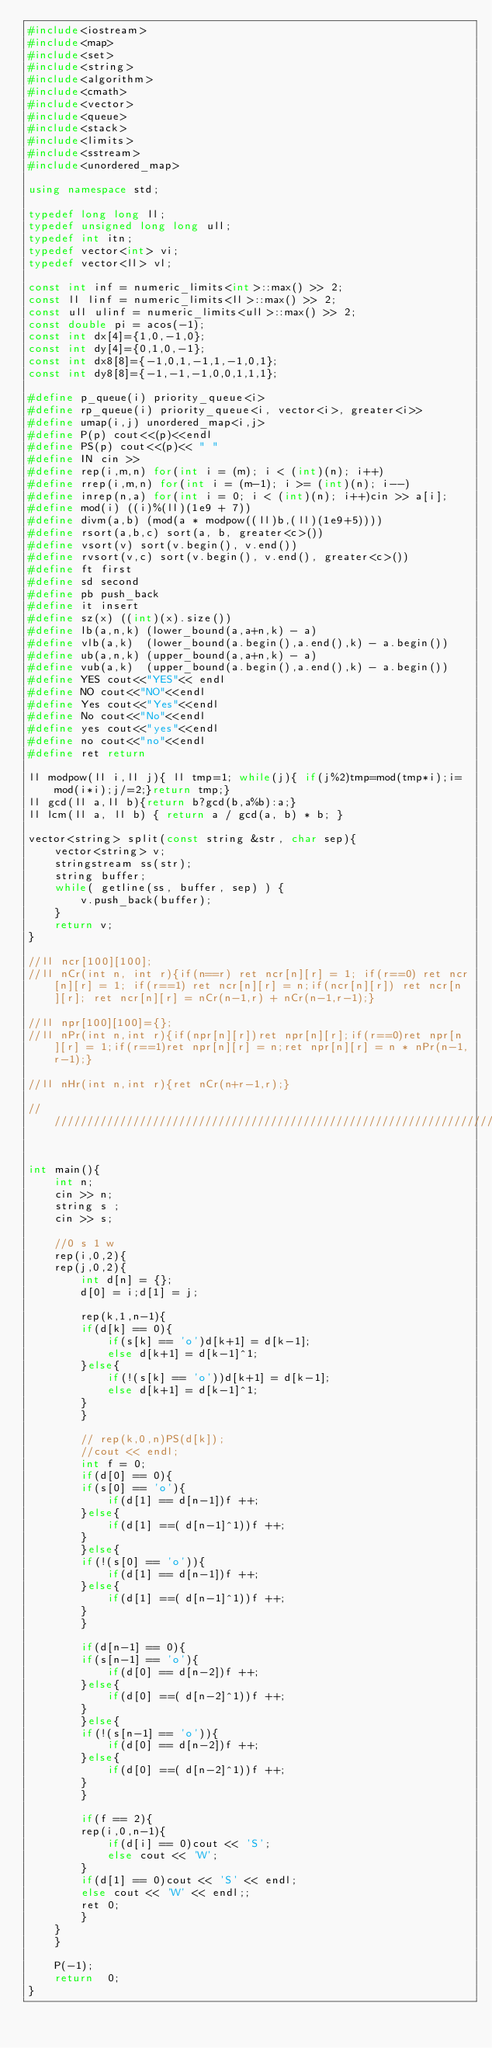Convert code to text. <code><loc_0><loc_0><loc_500><loc_500><_C++_>#include<iostream>
#include<map>
#include<set>
#include<string>
#include<algorithm>
#include<cmath>
#include<vector>
#include<queue>
#include<stack>
#include<limits>
#include<sstream> 
#include<unordered_map>      

using namespace std;

typedef long long ll;
typedef unsigned long long ull;
typedef int itn;
typedef vector<int> vi;
typedef vector<ll> vl;

const int inf = numeric_limits<int>::max() >> 2;
const ll linf = numeric_limits<ll>::max() >> 2;
const ull ulinf = numeric_limits<ull>::max() >> 2;
const double pi = acos(-1);
const int dx[4]={1,0,-1,0};
const int dy[4]={0,1,0,-1};
const int dx8[8]={-1,0,1,-1,1,-1,0,1};
const int dy8[8]={-1,-1,-1,0,0,1,1,1};

#define p_queue(i) priority_queue<i> 
#define rp_queue(i) priority_queue<i, vector<i>, greater<i>> 
#define umap(i,j) unordered_map<i,j>
#define P(p) cout<<(p)<<endl
#define PS(p) cout<<(p)<< " "
#define IN cin >> 
#define rep(i,m,n) for(int i = (m); i < (int)(n); i++)
#define rrep(i,m,n) for(int i = (m-1); i >= (int)(n); i--)
#define inrep(n,a) for(int i = 0; i < (int)(n); i++)cin >> a[i];
#define mod(i) ((i)%(ll)(1e9 + 7))
#define divm(a,b) (mod(a * modpow((ll)b,(ll)(1e9+5))))
#define rsort(a,b,c) sort(a, b, greater<c>())
#define vsort(v) sort(v.begin(), v.end())
#define rvsort(v,c) sort(v.begin(), v.end(), greater<c>()) 
#define ft first
#define sd second
#define pb push_back
#define it insert
#define sz(x) ((int)(x).size())
#define lb(a,n,k) (lower_bound(a,a+n,k) - a) 
#define vlb(a,k)  (lower_bound(a.begin(),a.end(),k) - a.begin())
#define ub(a,n,k) (upper_bound(a,a+n,k) - a) 
#define vub(a,k)  (upper_bound(a.begin(),a.end(),k) - a.begin())
#define YES cout<<"YES"<< endl
#define NO cout<<"NO"<<endl
#define Yes cout<<"Yes"<<endl
#define No cout<<"No"<<endl  
#define yes cout<<"yes"<<endl
#define no cout<<"no"<<endl
#define ret return

ll modpow(ll i,ll j){ ll tmp=1; while(j){ if(j%2)tmp=mod(tmp*i);i=mod(i*i);j/=2;}return tmp;}
ll gcd(ll a,ll b){return b?gcd(b,a%b):a;}
ll lcm(ll a, ll b) { return a / gcd(a, b) * b; }

vector<string> split(const string &str, char sep){
    vector<string> v;
    stringstream ss(str);
    string buffer;
    while( getline(ss, buffer, sep) ) {
        v.push_back(buffer);
    }
    return v;
}

//ll ncr[100][100];
//ll nCr(int n, int r){if(n==r) ret ncr[n][r] = 1; if(r==0) ret ncr[n][r] = 1; if(r==1) ret ncr[n][r] = n;if(ncr[n][r]) ret ncr[n][r]; ret ncr[n][r] = nCr(n-1,r) + nCr(n-1,r-1);}

//ll npr[100][100]={};
//ll nPr(int n,int r){if(npr[n][r])ret npr[n][r];if(r==0)ret npr[n][r] = 1;if(r==1)ret npr[n][r] = n;ret npr[n][r] = n * nPr(n-1,r-1);}

//ll nHr(int n,int r){ret nCr(n+r-1,r);}

///////////////////////////////////////////////////////////////////////////


int main(){
    int n;
    cin >> n;
    string s ;
    cin >> s;

    //0 s 1 w
    rep(i,0,2){
	rep(j,0,2){
	    int d[n] = {};
	    d[0] = i;d[1] = j;
	    
	    rep(k,1,n-1){
		if(d[k] == 0){
		    if(s[k] == 'o')d[k+1] = d[k-1];
		    else d[k+1] = d[k-1]^1;
		}else{
		    if(!(s[k] == 'o'))d[k+1] = d[k-1];
		    else d[k+1] = d[k-1]^1;
		}
	    }

	    // rep(k,0,n)PS(d[k]);
	    //cout << endl;
	    int f = 0;
	    if(d[0] == 0){
		if(s[0] == 'o'){
		    if(d[1] == d[n-1])f ++;
		}else{
		    if(d[1] ==( d[n-1]^1))f ++;
		}
	    }else{
		if(!(s[0] == 'o')){
		    if(d[1] == d[n-1])f ++;
		}else{
		    if(d[1] ==( d[n-1]^1))f ++;
		}
	    }

	    if(d[n-1] == 0){
		if(s[n-1] == 'o'){
		    if(d[0] == d[n-2])f ++;
		}else{
		    if(d[0] ==( d[n-2]^1))f ++;
		}
	    }else{
		if(!(s[n-1] == 'o')){
		    if(d[0] == d[n-2])f ++;
		}else{
		    if(d[0] ==( d[n-2]^1))f ++;
		}
	    }

	    if(f == 2){
		rep(i,0,n-1){
		    if(d[i] == 0)cout << 'S';
		    else cout << 'W';
		}
		if(d[1] == 0)cout << 'S' << endl;
		else cout << 'W' << endl;;
		ret 0;
	    }
	}
    }

    P(-1);
    return  0;
}
</code> 